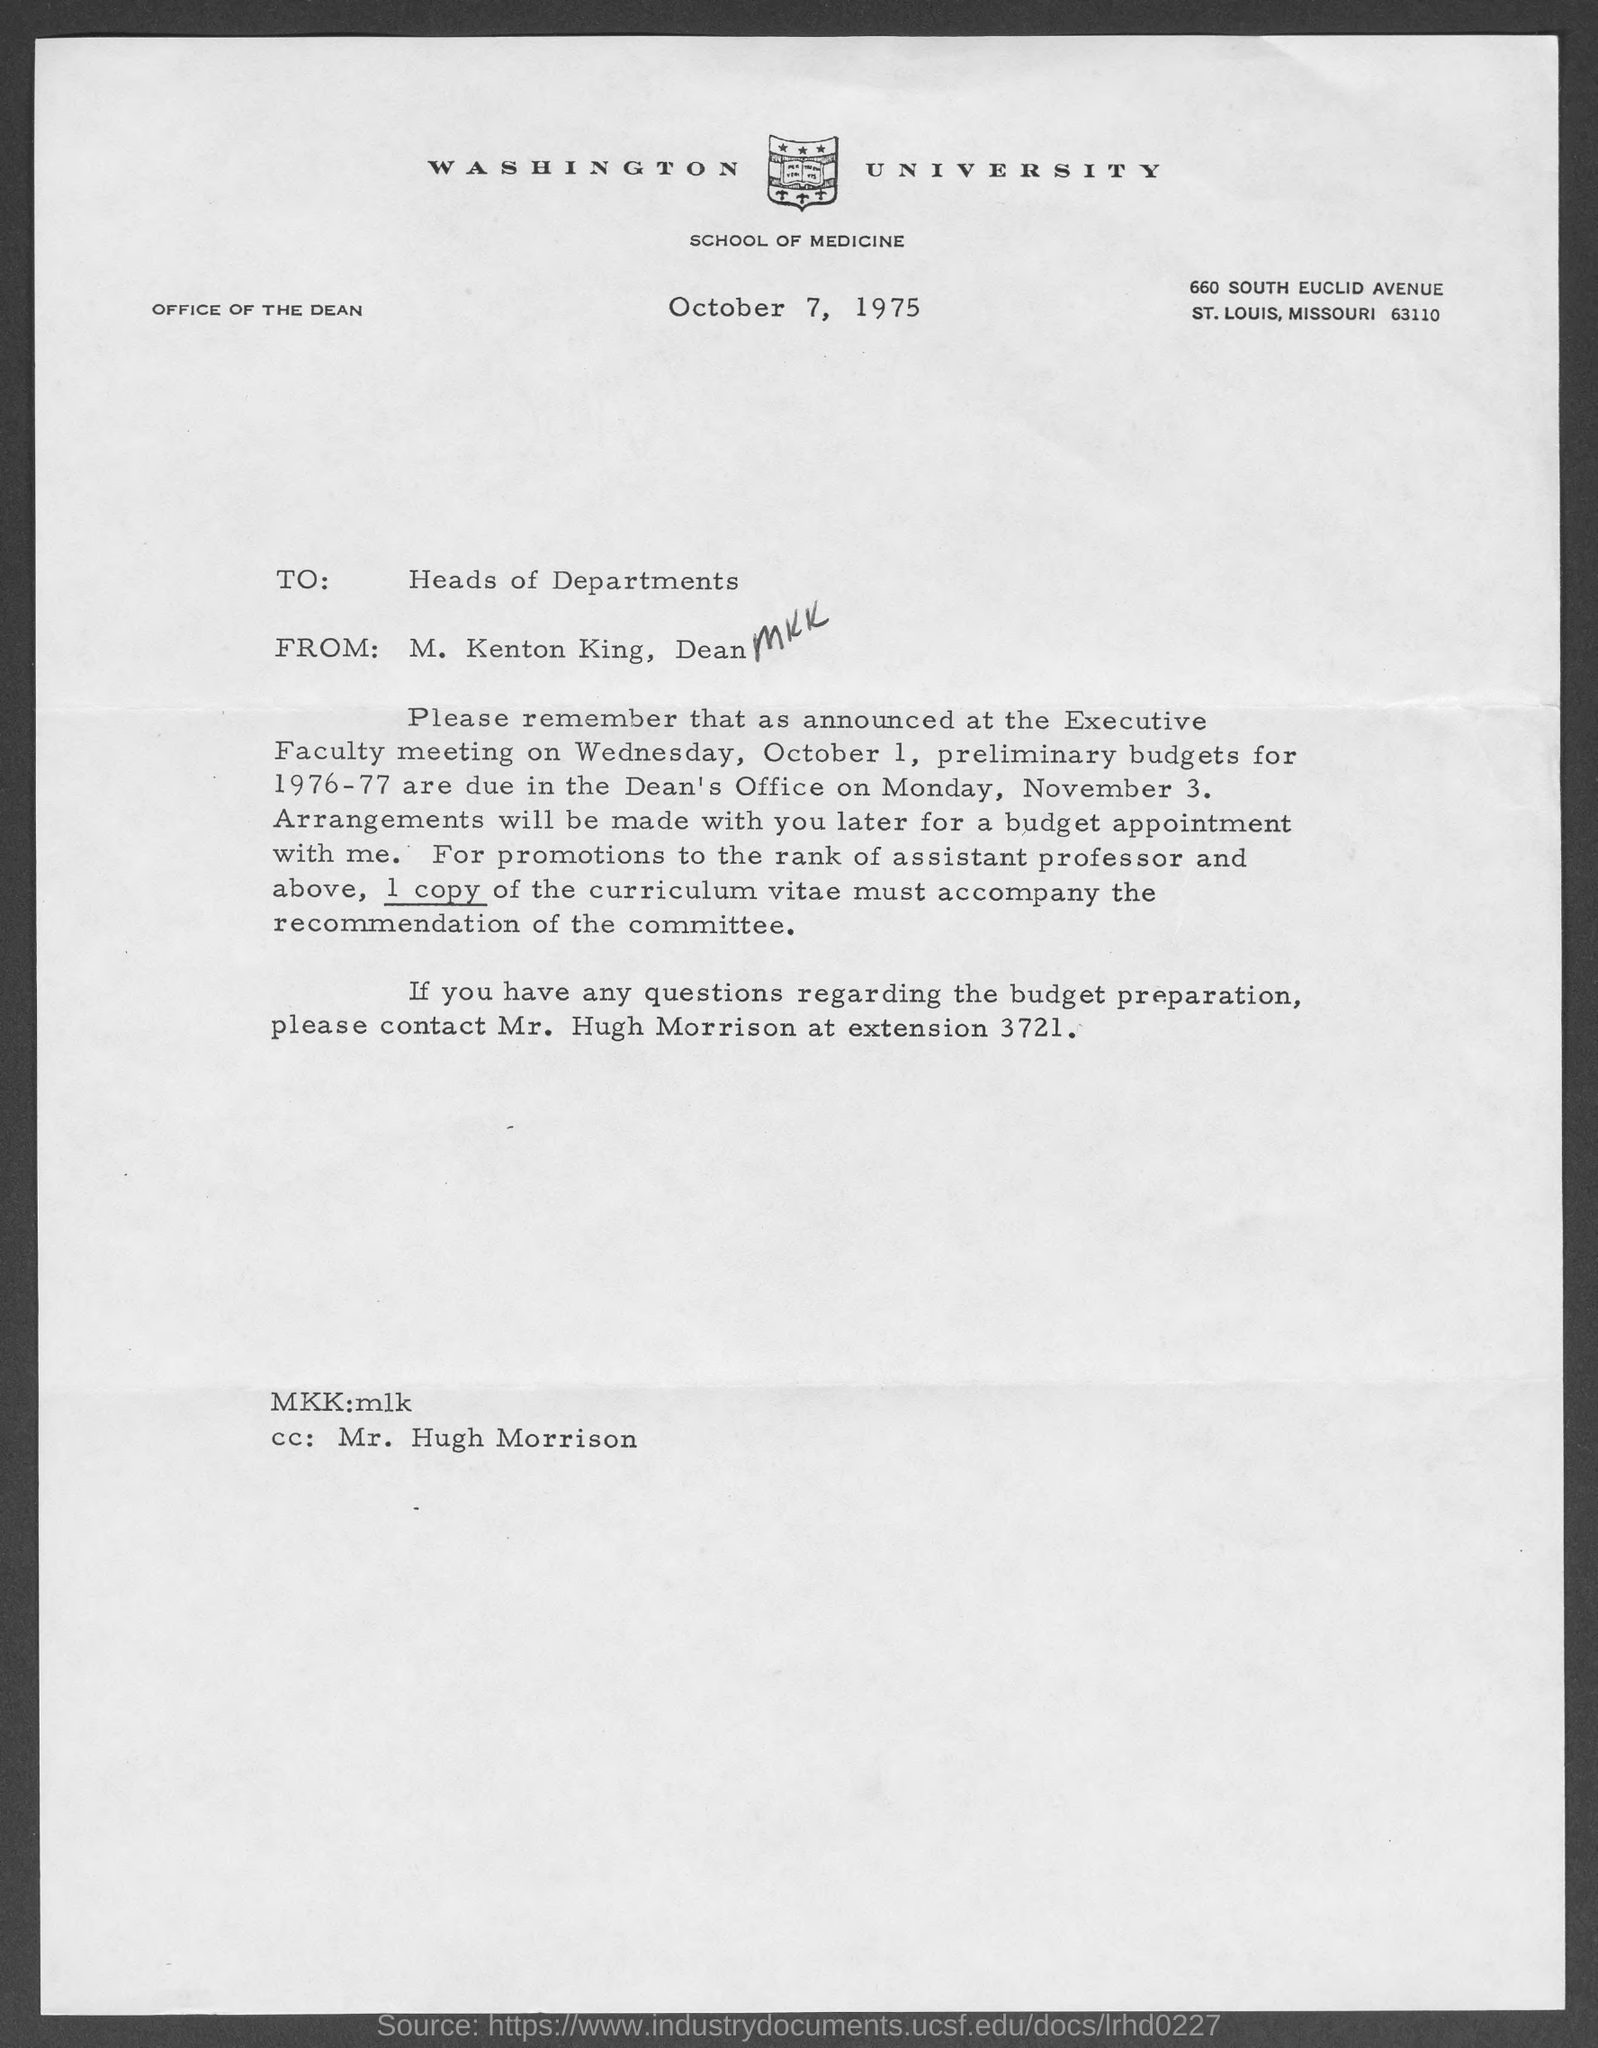Identify some key points in this picture. The letter is from M. Kenton King, Dean. The letter is addressed to the Heads of Departments. The extension number of Hugh Morrison is 3721... The document is dated October 7, 1975. The individual responsible for managing the budget preparation is Mr. Hugh Morrison. 